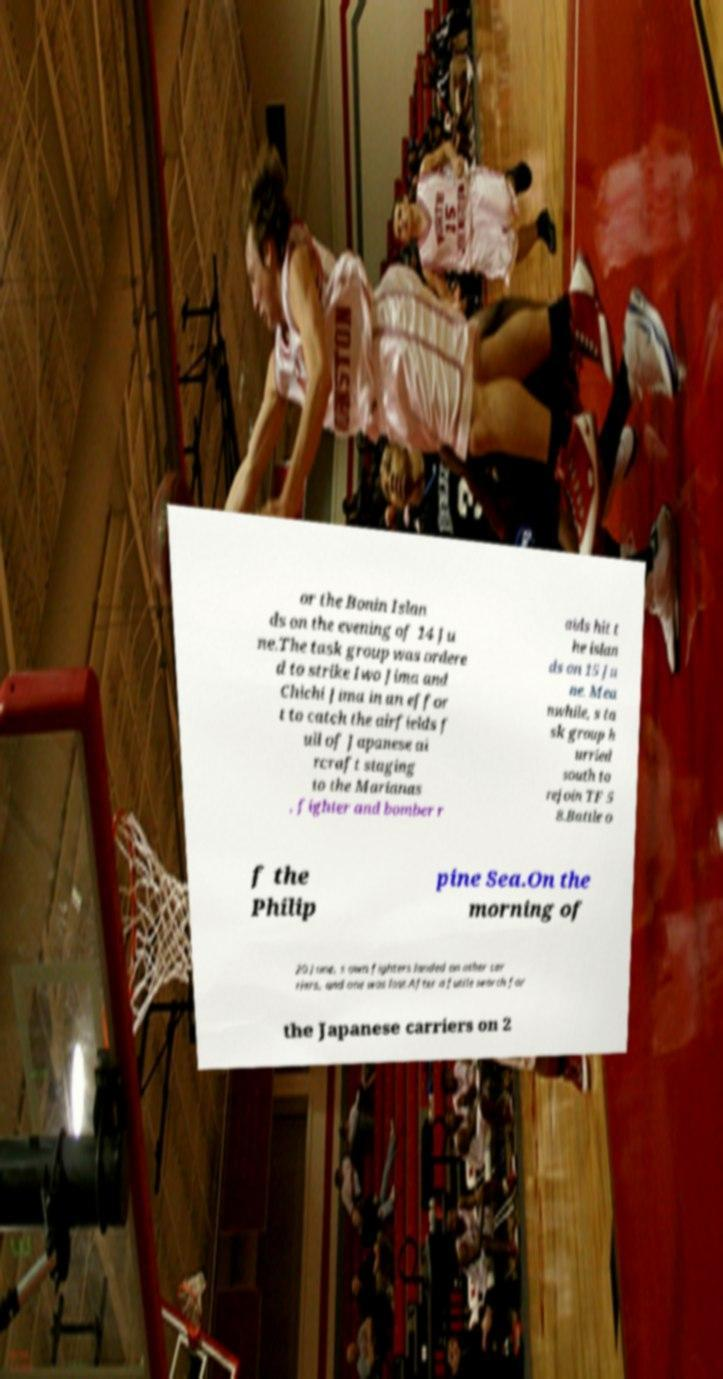Can you accurately transcribe the text from the provided image for me? or the Bonin Islan ds on the evening of 14 Ju ne.The task group was ordere d to strike Iwo Jima and Chichi Jima in an effor t to catch the airfields f ull of Japanese ai rcraft staging to the Marianas , fighter and bomber r aids hit t he islan ds on 15 Ju ne. Mea nwhile, s ta sk group h urried south to rejoin TF 5 8.Battle o f the Philip pine Sea.On the morning of 20 June, s own fighters landed on other car riers, and one was lost.After a futile search for the Japanese carriers on 2 